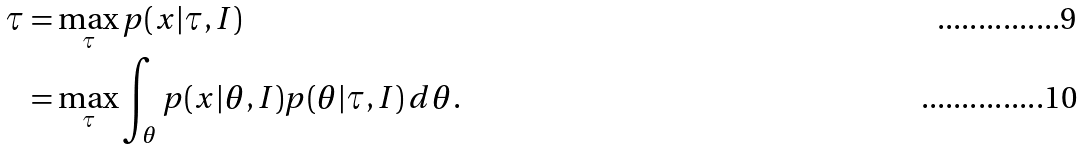Convert formula to latex. <formula><loc_0><loc_0><loc_500><loc_500>\tau & = \max _ { \tau } p ( x | \tau , I ) \\ & = \max _ { \tau } \int _ { \theta } p ( x | \theta , I ) p ( \theta | \tau , I ) \, d \theta .</formula> 